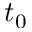<formula> <loc_0><loc_0><loc_500><loc_500>t _ { 0 }</formula> 